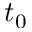<formula> <loc_0><loc_0><loc_500><loc_500>t _ { 0 }</formula> 